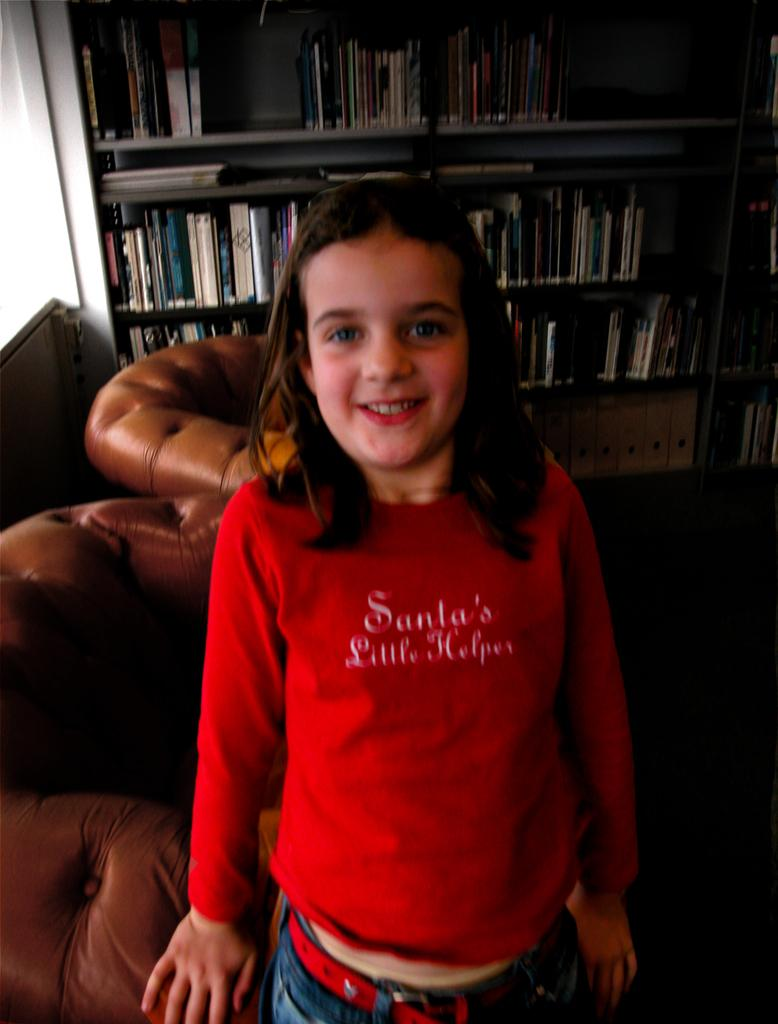What is the main subject of the image? The main subject of the image is a kid. What can be observed about the kid's attire? The kid is wearing clothes. What type of furniture is present in front of the window? There are couches in front of the window. What is located at the top of the image? There is a rack at the top of the image. What items are stored on the rack? The rack contains some books. How does the kid rub their eyes in the image? There is no indication in the image that the kid is rubbing their eyes. Can you see any goldfish swimming in the image? There are no goldfish present in the image. 